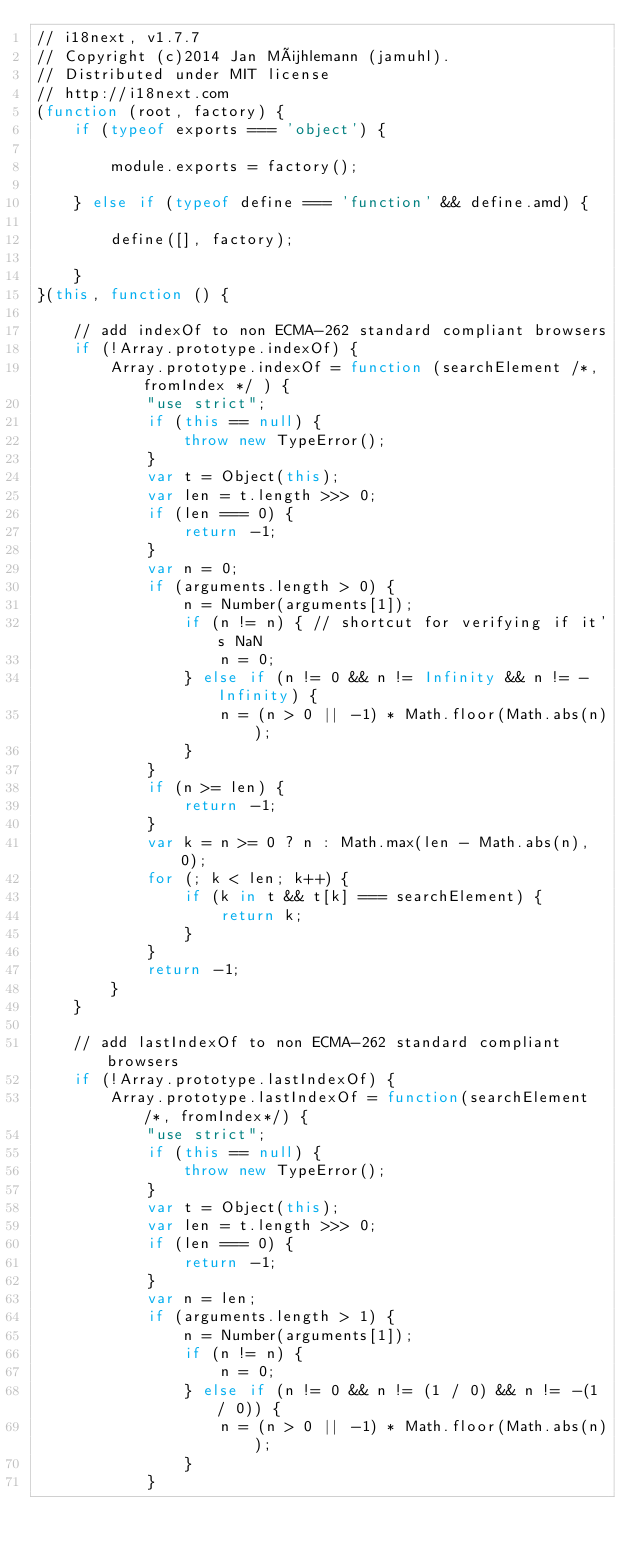Convert code to text. <code><loc_0><loc_0><loc_500><loc_500><_JavaScript_>// i18next, v1.7.7
// Copyright (c)2014 Jan Mühlemann (jamuhl).
// Distributed under MIT license
// http://i18next.com
(function (root, factory) {
    if (typeof exports === 'object') {

        module.exports = factory();

    } else if (typeof define === 'function' && define.amd) {

        define([], factory);

    } 
}(this, function () {

    // add indexOf to non ECMA-262 standard compliant browsers
    if (!Array.prototype.indexOf) {
        Array.prototype.indexOf = function (searchElement /*, fromIndex */ ) {
            "use strict";
            if (this == null) {
                throw new TypeError();
            }
            var t = Object(this);
            var len = t.length >>> 0;
            if (len === 0) {
                return -1;
            }
            var n = 0;
            if (arguments.length > 0) {
                n = Number(arguments[1]);
                if (n != n) { // shortcut for verifying if it's NaN
                    n = 0;
                } else if (n != 0 && n != Infinity && n != -Infinity) {
                    n = (n > 0 || -1) * Math.floor(Math.abs(n));
                }
            }
            if (n >= len) {
                return -1;
            }
            var k = n >= 0 ? n : Math.max(len - Math.abs(n), 0);
            for (; k < len; k++) {
                if (k in t && t[k] === searchElement) {
                    return k;
                }
            }
            return -1;
        }
    }
    
    // add lastIndexOf to non ECMA-262 standard compliant browsers
    if (!Array.prototype.lastIndexOf) {
        Array.prototype.lastIndexOf = function(searchElement /*, fromIndex*/) {
            "use strict";
            if (this == null) {
                throw new TypeError();
            }
            var t = Object(this);
            var len = t.length >>> 0;
            if (len === 0) {
                return -1;
            }
            var n = len;
            if (arguments.length > 1) {
                n = Number(arguments[1]);
                if (n != n) {
                    n = 0;
                } else if (n != 0 && n != (1 / 0) && n != -(1 / 0)) {
                    n = (n > 0 || -1) * Math.floor(Math.abs(n));
                }
            }</code> 